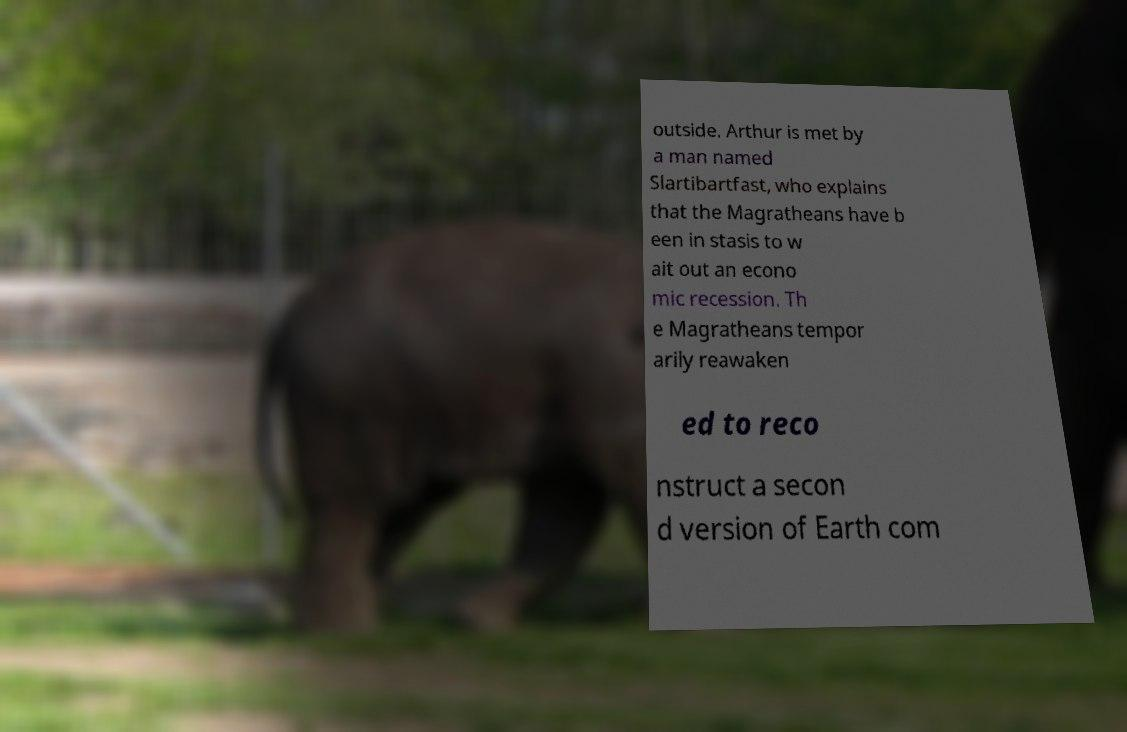Please identify and transcribe the text found in this image. outside. Arthur is met by a man named Slartibartfast, who explains that the Magratheans have b een in stasis to w ait out an econo mic recession. Th e Magratheans tempor arily reawaken ed to reco nstruct a secon d version of Earth com 